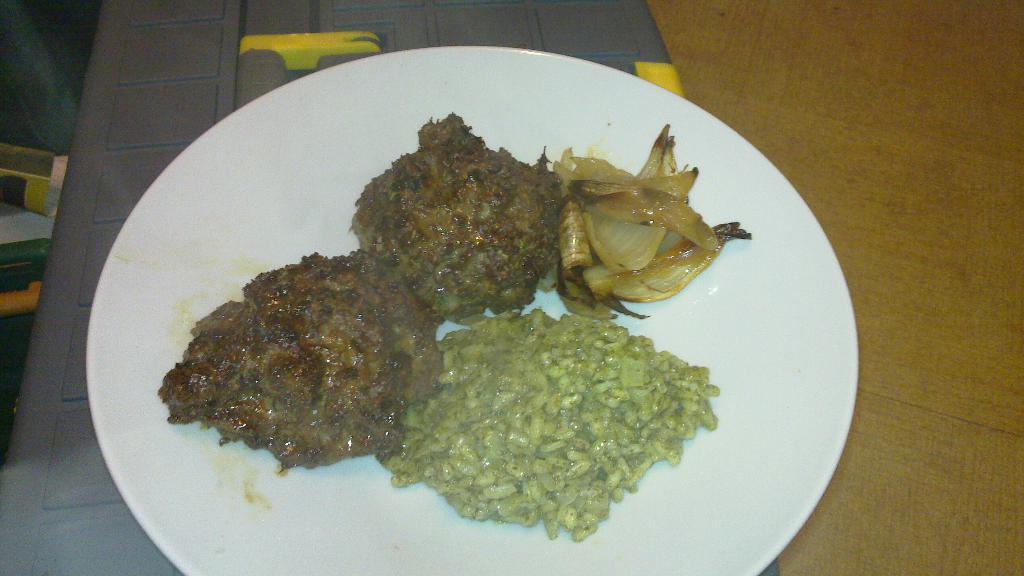What is on the plate that is visible in the image? There is food on a plate in the image. Where is the plate located in the image? The plate is placed on a table in the image. What else can be seen in the image besides the plate and food? There are other objects present in the image. What verse is written on the letter in the image? There is no letter or verse present in the image. Can you describe the type of swing in the image? There is no swing present in the image. 